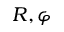<formula> <loc_0><loc_0><loc_500><loc_500>R , \varphi</formula> 